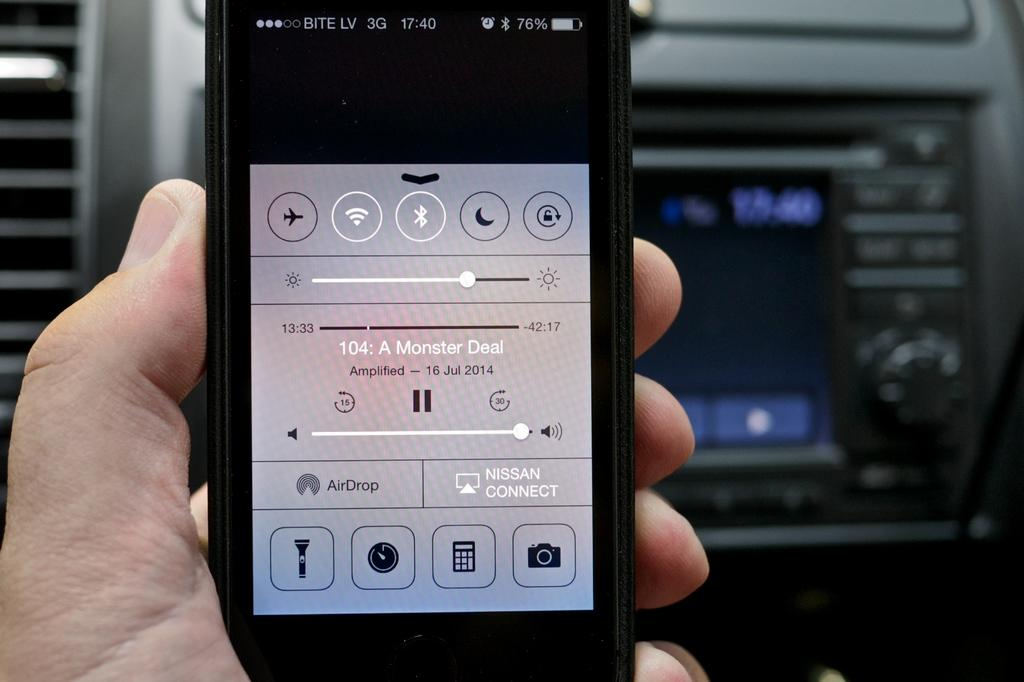<image>
Write a terse but informative summary of the picture. A phone has an audio file on the screen titled A Monster Deal. 